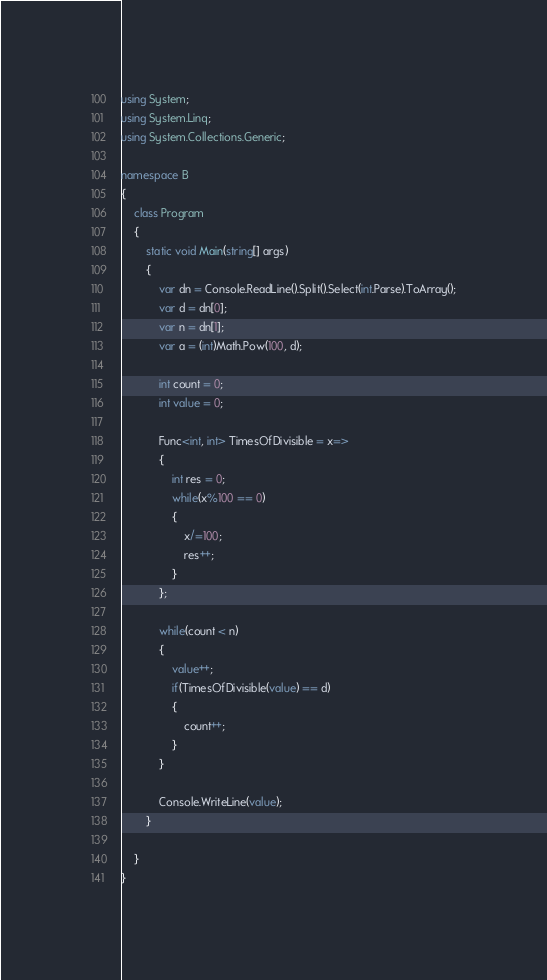<code> <loc_0><loc_0><loc_500><loc_500><_C#_>using System;
using System.Linq;
using System.Collections.Generic;

namespace B
{
    class Program
    {
        static void Main(string[] args)
        {
            var dn = Console.ReadLine().Split().Select(int.Parse).ToArray();
            var d = dn[0];
            var n = dn[1];
            var a = (int)Math.Pow(100, d);

            int count = 0;
            int value = 0;

            Func<int, int> TimesOfDivisible = x=>
            {
                int res = 0;
                while(x%100 == 0)
                {
                    x/=100;
                    res++;
                }
            };

            while(count < n)
            {
                value++;
                if(TimesOfDivisible(value) == d)
                {
                    count++;
                }
            }

            Console.WriteLine(value);
        }

    }
}
</code> 